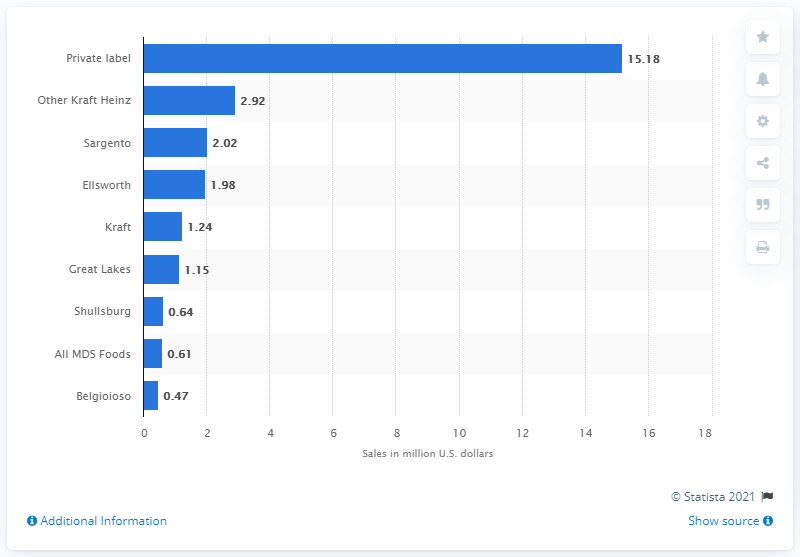Highlight a few significant elements in this photo. According to data for the 12 weeks ended January 26, 2020, Ellsworth was the fourth highest-ranking natural cheese cube brand in the United States. 